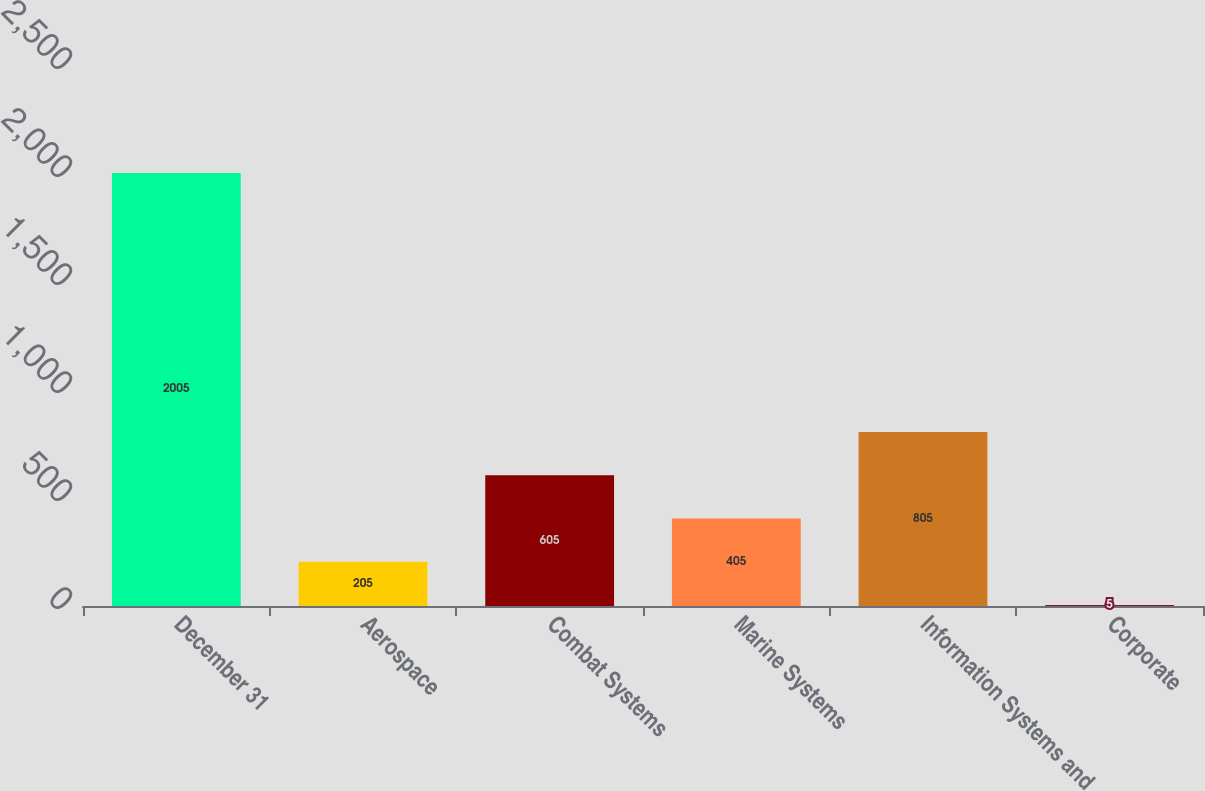Convert chart to OTSL. <chart><loc_0><loc_0><loc_500><loc_500><bar_chart><fcel>December 31<fcel>Aerospace<fcel>Combat Systems<fcel>Marine Systems<fcel>Information Systems and<fcel>Corporate<nl><fcel>2005<fcel>205<fcel>605<fcel>405<fcel>805<fcel>5<nl></chart> 